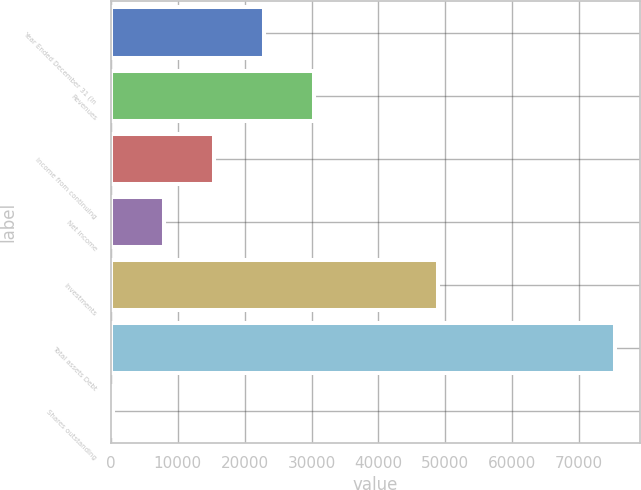Convert chart. <chart><loc_0><loc_0><loc_500><loc_500><bar_chart><fcel>Year Ended December 31 (In<fcel>Revenues<fcel>Income from continuing<fcel>Net income<fcel>Investments<fcel>Total assets Debt<fcel>Shares outstanding<nl><fcel>22858<fcel>30345.2<fcel>15370.9<fcel>7883.73<fcel>48943<fcel>75268<fcel>396.59<nl></chart> 